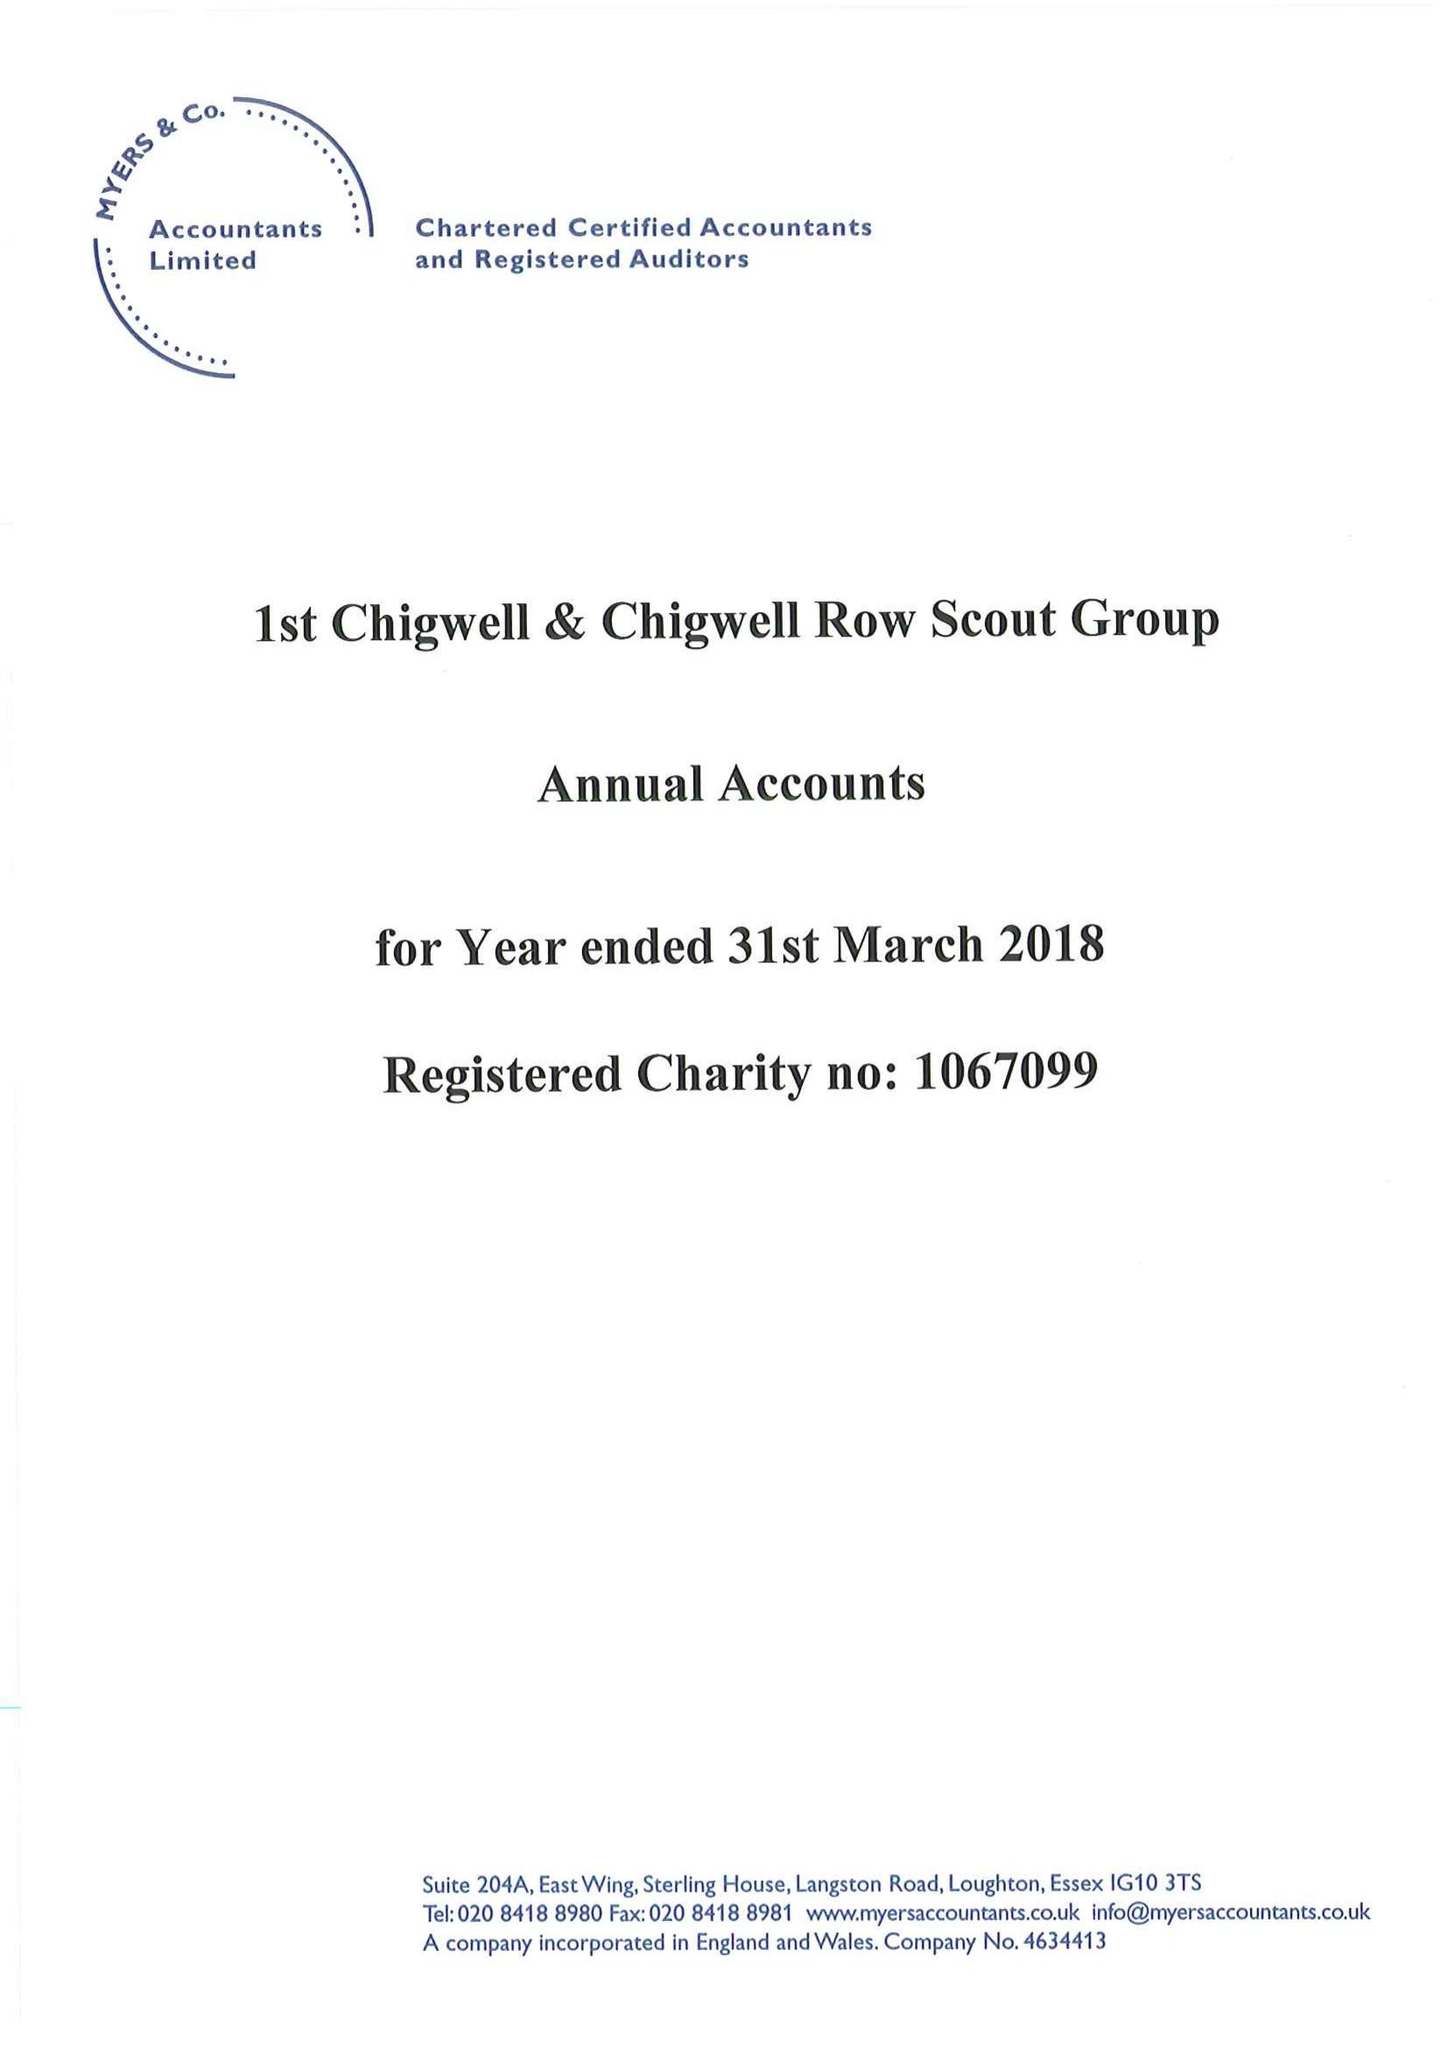What is the value for the address__post_town?
Answer the question using a single word or phrase. None 